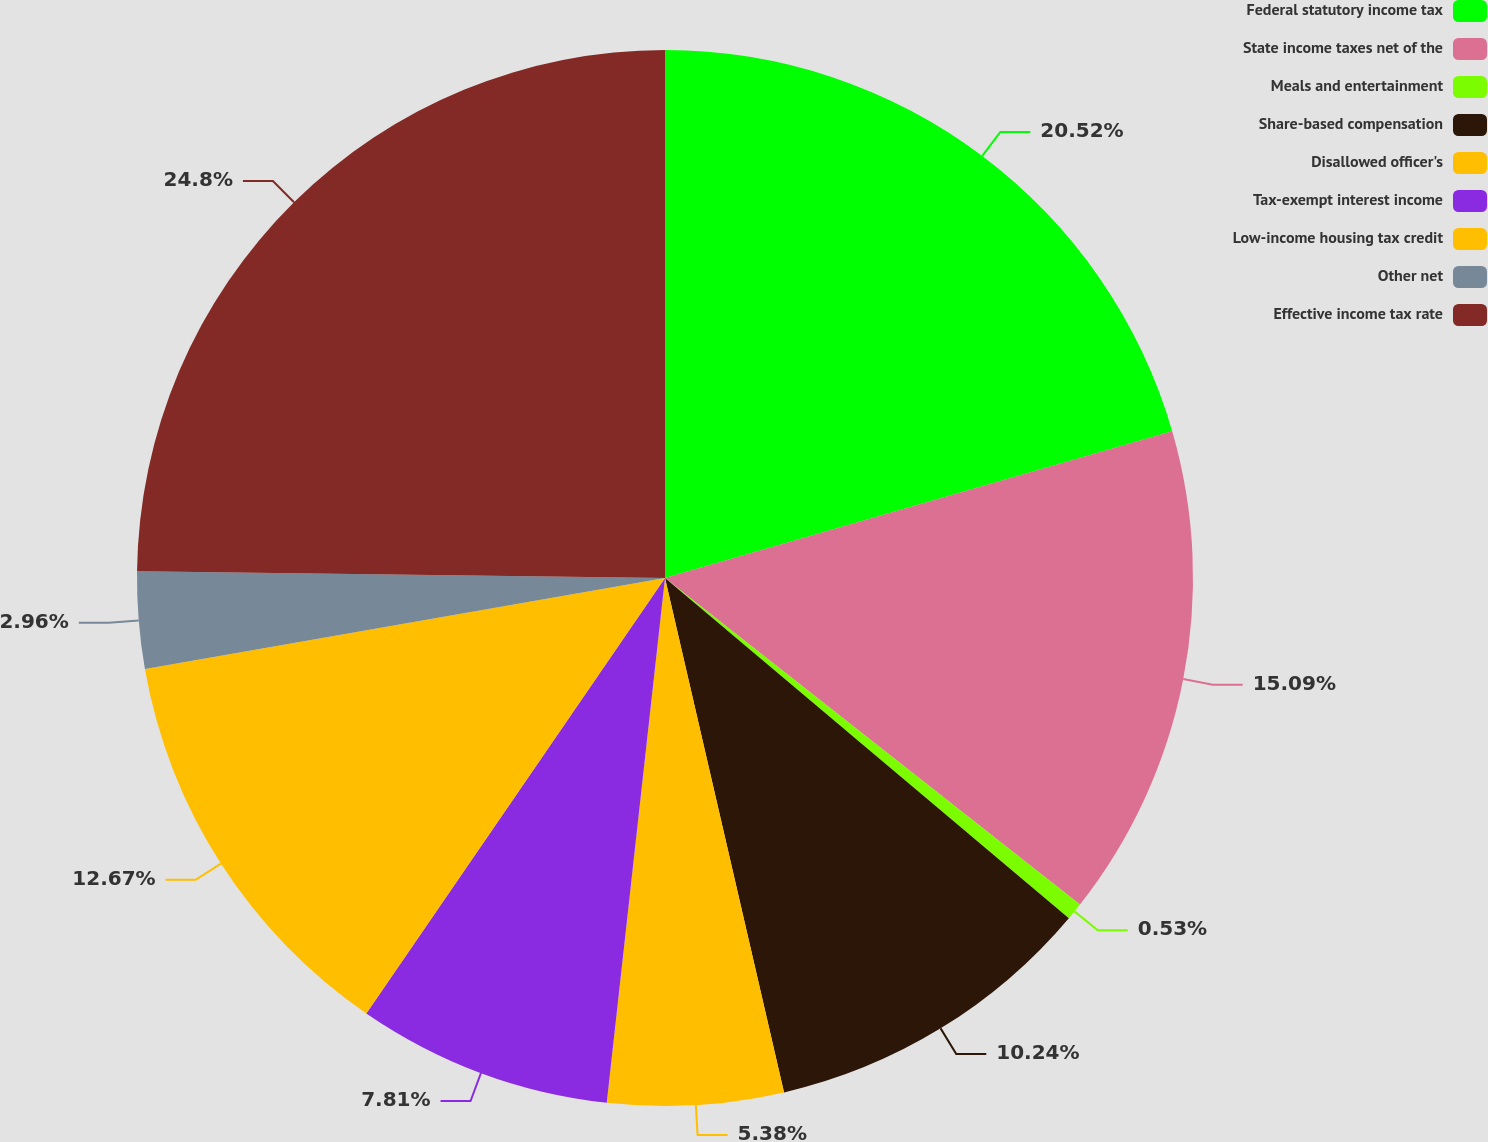Convert chart to OTSL. <chart><loc_0><loc_0><loc_500><loc_500><pie_chart><fcel>Federal statutory income tax<fcel>State income taxes net of the<fcel>Meals and entertainment<fcel>Share-based compensation<fcel>Disallowed officer's<fcel>Tax-exempt interest income<fcel>Low-income housing tax credit<fcel>Other net<fcel>Effective income tax rate<nl><fcel>20.52%<fcel>15.09%<fcel>0.53%<fcel>10.24%<fcel>5.38%<fcel>7.81%<fcel>12.67%<fcel>2.96%<fcel>24.8%<nl></chart> 